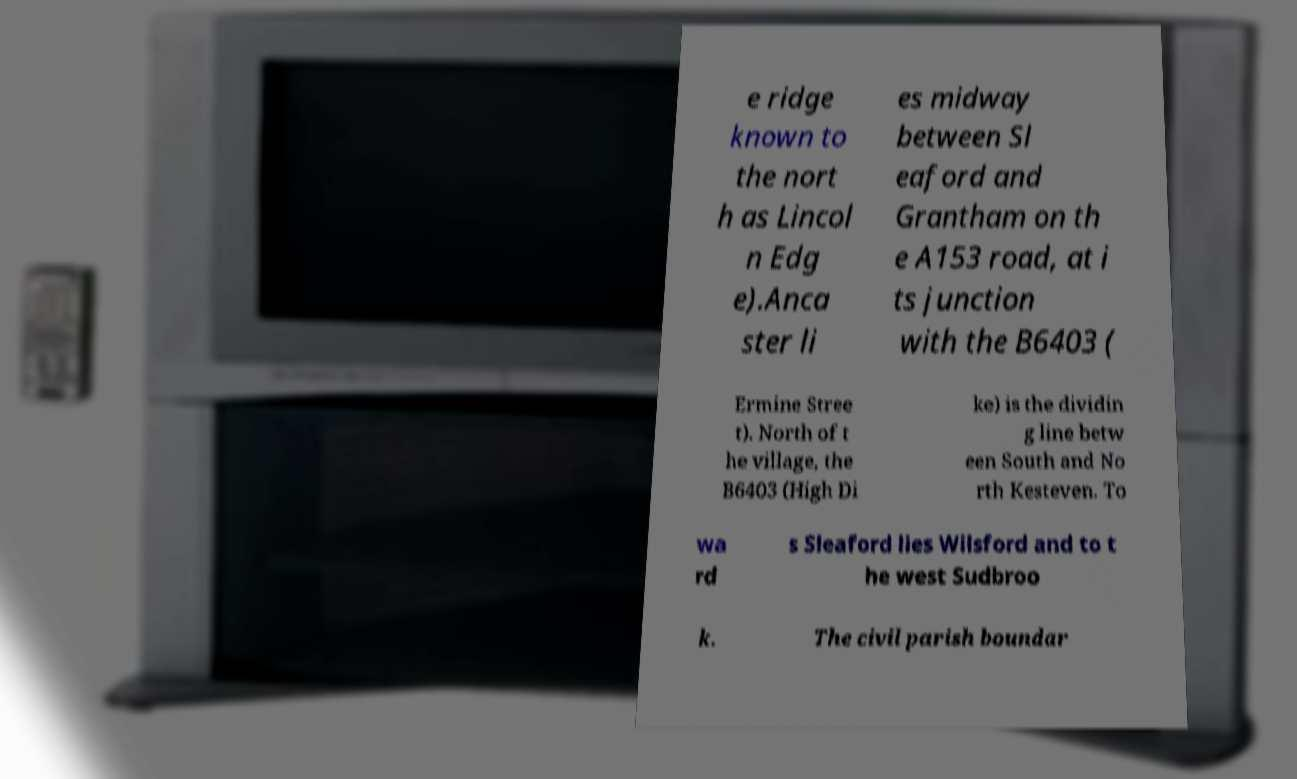Please read and relay the text visible in this image. What does it say? e ridge known to the nort h as Lincol n Edg e).Anca ster li es midway between Sl eaford and Grantham on th e A153 road, at i ts junction with the B6403 ( Ermine Stree t). North of t he village, the B6403 (High Di ke) is the dividin g line betw een South and No rth Kesteven. To wa rd s Sleaford lies Wilsford and to t he west Sudbroo k. The civil parish boundar 